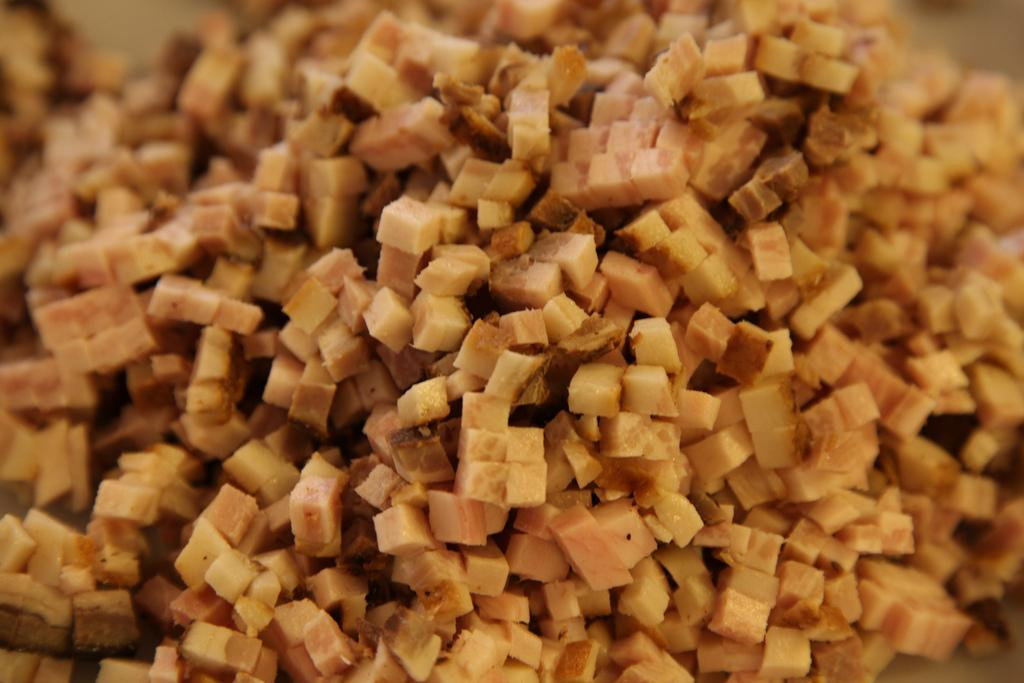What is the main subject of the image? There is a food item in the image. Can you describe the appearance of the food item? The food item is chopped. How many cattle are grazing in the background of the image? There is no background or cattle present in the image; it only features a chopped food item. What type of paper is visible in the image? There is no paper present in the image. 